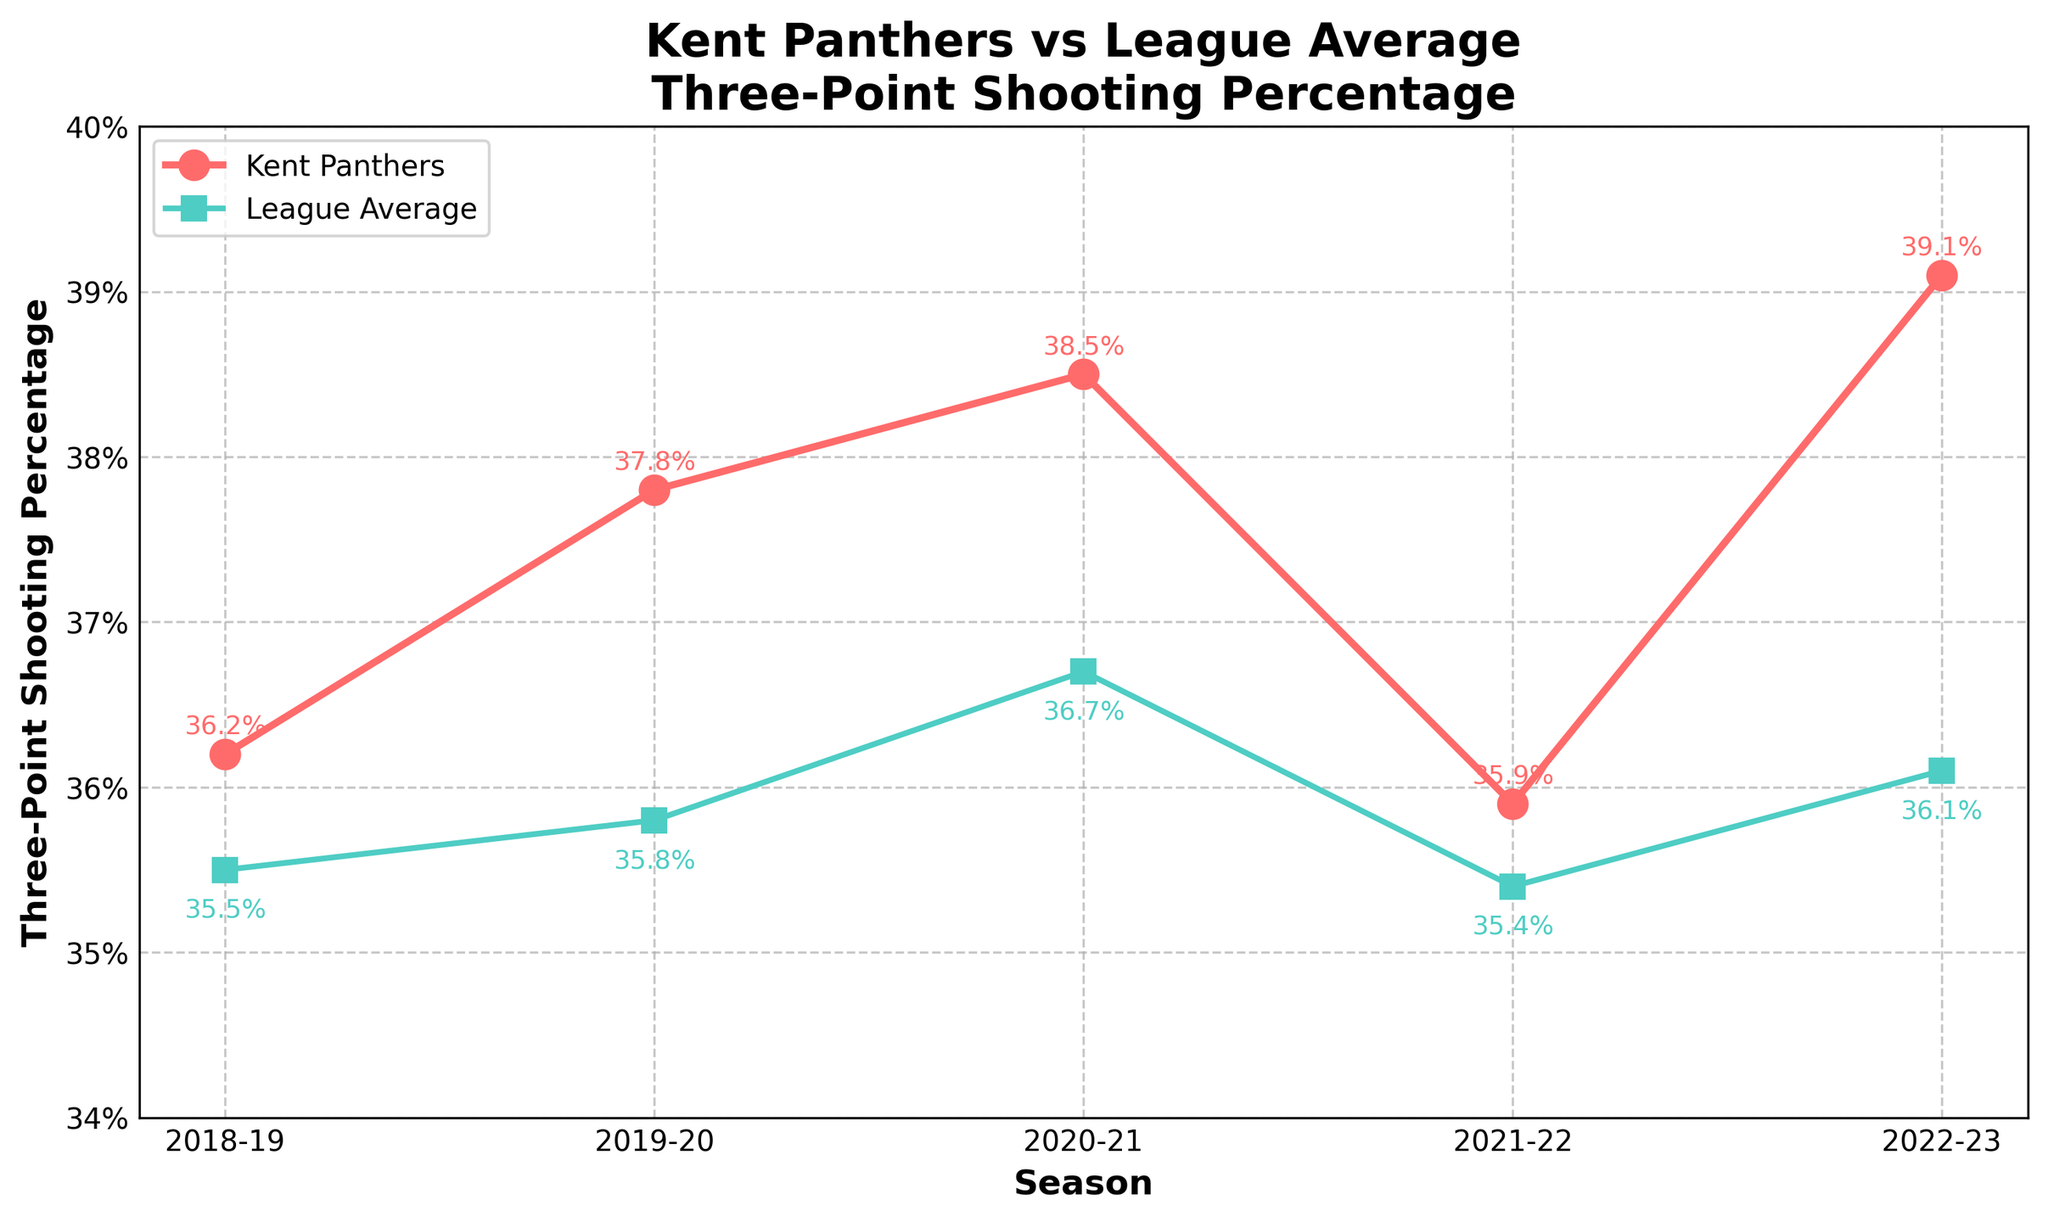What season did the Kent Panthers have the highest three-point shooting percentage? The Kent Panthers' highest three-point percentage is represented by the highest point on their line. By looking at the figure, it's clear that the highest peak is in the 2022-23 season.
Answer: 2022-23 How does the Kent Panthers' three-point shooting percentage in the 2020-21 season compare to the league average in that same season? To compare, we need to check the position of both points on the respective lines for the 2020-21 season. The Panthers have a higher value at 38.5% compared to the league average of 36.7%.
Answer: Higher What is the three-point shooting percentage trend of the Kent Panthers over the five years shown? The trend can be observed by the slope of the line. There is an increasing trend from 2018-19 to 2020-21, then it slightly decreases in 2021-22, followed by a sharp increase in 2022-23.
Answer: Increasing, then decreasing, then sharply increasing What is the average three-point shooting percentage difference between the Kent Panthers and the league average over the five years? Calculate the difference for each year and then find the average: (36.2-35.5) + (37.8-35.8) + (38.5-36.7) + (35.9-35.4) + (39.1-36.1) = 0.7 + 2.0 + 1.8 + 0.5 + 3.0 = 8. Total difference: 8, Number of seasons: 5, Average difference = 8/5 = 1.6
Answer: 1.6% Did the Kent Panthers ever fall below the league average in any of the seasons shown? By comparing the values of the Kent Panthers' line to the league average line for each season, we see that the Panthers never fall below the league average in any of the seasons.
Answer: No In which season is the gap between the Kent Panthers' and the league's three-point shooting percentage the smallest? Calculate the gap for each season by subtracting the league average from the Panthers' values: 0.7, 2.0, 1.8, 0.5, and 3.0. The smallest gap is 0.5 in the 2021-22 season.
Answer: 2021-22 How much did the Kent Panthers' three-point shooting percentage increase from the 2021-22 season to the 2022-23 season? Subtract the percentage of 2021-22 from that of 2022-23: 39.1% - 35.9% = 3.2%.
Answer: 3.2% Which season had the smallest positive improvement in the Kent Panthers' three-point shooting percentage over the previous season? Calculate the improvement for each season: 2019-20 (1.6), 2020-21 (0.7), 2021-22 (-2.6), 2022-23 (3.2). The smallest positive improvement is in 2020-21.
Answer: 2020-21 In which season did the league average three-point shooting percentage peak, and what was the value? The peak value can be found by identifying the highest point on the league average line, which is in the 2020-21 season at 36.7%.
Answer: 2020-21, 36.7% 